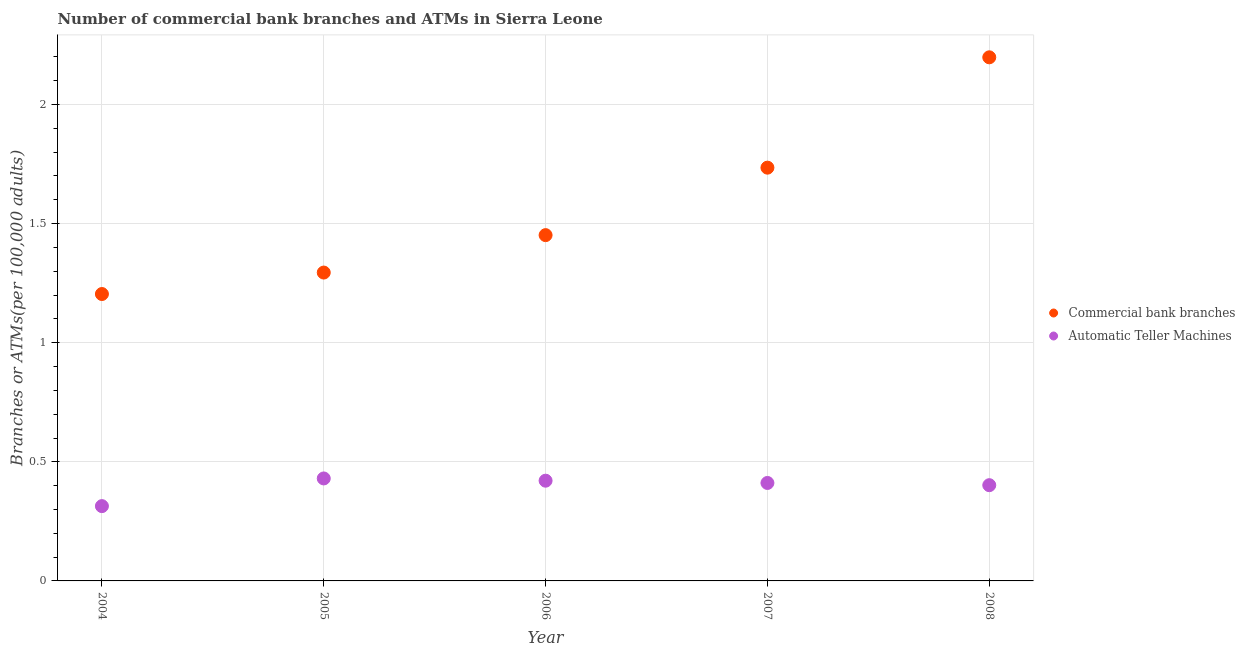How many different coloured dotlines are there?
Your response must be concise. 2. What is the number of commercal bank branches in 2005?
Offer a terse response. 1.29. Across all years, what is the maximum number of atms?
Your answer should be very brief. 0.43. Across all years, what is the minimum number of commercal bank branches?
Your response must be concise. 1.2. In which year was the number of commercal bank branches maximum?
Ensure brevity in your answer.  2008. What is the total number of atms in the graph?
Your answer should be compact. 1.98. What is the difference between the number of commercal bank branches in 2007 and that in 2008?
Your response must be concise. -0.46. What is the difference between the number of atms in 2007 and the number of commercal bank branches in 2004?
Your answer should be very brief. -0.79. What is the average number of commercal bank branches per year?
Make the answer very short. 1.58. In the year 2006, what is the difference between the number of commercal bank branches and number of atms?
Provide a short and direct response. 1.03. What is the ratio of the number of atms in 2006 to that in 2007?
Offer a very short reply. 1.02. Is the difference between the number of commercal bank branches in 2004 and 2005 greater than the difference between the number of atms in 2004 and 2005?
Offer a terse response. Yes. What is the difference between the highest and the second highest number of commercal bank branches?
Ensure brevity in your answer.  0.46. What is the difference between the highest and the lowest number of atms?
Make the answer very short. 0.12. In how many years, is the number of atms greater than the average number of atms taken over all years?
Make the answer very short. 4. Is the sum of the number of atms in 2005 and 2007 greater than the maximum number of commercal bank branches across all years?
Offer a terse response. No. Does the number of atms monotonically increase over the years?
Provide a succinct answer. No. How many dotlines are there?
Make the answer very short. 2. How many years are there in the graph?
Provide a succinct answer. 5. What is the difference between two consecutive major ticks on the Y-axis?
Keep it short and to the point. 0.5. Are the values on the major ticks of Y-axis written in scientific E-notation?
Make the answer very short. No. Does the graph contain any zero values?
Offer a very short reply. No. Does the graph contain grids?
Keep it short and to the point. Yes. How many legend labels are there?
Your answer should be compact. 2. What is the title of the graph?
Your answer should be very brief. Number of commercial bank branches and ATMs in Sierra Leone. Does "Net National savings" appear as one of the legend labels in the graph?
Make the answer very short. No. What is the label or title of the X-axis?
Your answer should be very brief. Year. What is the label or title of the Y-axis?
Provide a succinct answer. Branches or ATMs(per 100,0 adults). What is the Branches or ATMs(per 100,000 adults) of Commercial bank branches in 2004?
Provide a short and direct response. 1.2. What is the Branches or ATMs(per 100,000 adults) of Automatic Teller Machines in 2004?
Make the answer very short. 0.31. What is the Branches or ATMs(per 100,000 adults) in Commercial bank branches in 2005?
Offer a terse response. 1.29. What is the Branches or ATMs(per 100,000 adults) of Automatic Teller Machines in 2005?
Offer a terse response. 0.43. What is the Branches or ATMs(per 100,000 adults) of Commercial bank branches in 2006?
Offer a very short reply. 1.45. What is the Branches or ATMs(per 100,000 adults) of Automatic Teller Machines in 2006?
Give a very brief answer. 0.42. What is the Branches or ATMs(per 100,000 adults) of Commercial bank branches in 2007?
Provide a succinct answer. 1.73. What is the Branches or ATMs(per 100,000 adults) in Automatic Teller Machines in 2007?
Offer a very short reply. 0.41. What is the Branches or ATMs(per 100,000 adults) in Commercial bank branches in 2008?
Provide a short and direct response. 2.2. What is the Branches or ATMs(per 100,000 adults) in Automatic Teller Machines in 2008?
Your response must be concise. 0.4. Across all years, what is the maximum Branches or ATMs(per 100,000 adults) in Commercial bank branches?
Provide a succinct answer. 2.2. Across all years, what is the maximum Branches or ATMs(per 100,000 adults) in Automatic Teller Machines?
Your answer should be very brief. 0.43. Across all years, what is the minimum Branches or ATMs(per 100,000 adults) of Commercial bank branches?
Your answer should be very brief. 1.2. Across all years, what is the minimum Branches or ATMs(per 100,000 adults) of Automatic Teller Machines?
Give a very brief answer. 0.31. What is the total Branches or ATMs(per 100,000 adults) of Commercial bank branches in the graph?
Offer a very short reply. 7.88. What is the total Branches or ATMs(per 100,000 adults) in Automatic Teller Machines in the graph?
Your answer should be compact. 1.98. What is the difference between the Branches or ATMs(per 100,000 adults) of Commercial bank branches in 2004 and that in 2005?
Offer a very short reply. -0.09. What is the difference between the Branches or ATMs(per 100,000 adults) in Automatic Teller Machines in 2004 and that in 2005?
Your response must be concise. -0.12. What is the difference between the Branches or ATMs(per 100,000 adults) in Commercial bank branches in 2004 and that in 2006?
Keep it short and to the point. -0.25. What is the difference between the Branches or ATMs(per 100,000 adults) in Automatic Teller Machines in 2004 and that in 2006?
Your answer should be very brief. -0.11. What is the difference between the Branches or ATMs(per 100,000 adults) in Commercial bank branches in 2004 and that in 2007?
Provide a succinct answer. -0.53. What is the difference between the Branches or ATMs(per 100,000 adults) of Automatic Teller Machines in 2004 and that in 2007?
Offer a very short reply. -0.1. What is the difference between the Branches or ATMs(per 100,000 adults) in Commercial bank branches in 2004 and that in 2008?
Offer a very short reply. -0.99. What is the difference between the Branches or ATMs(per 100,000 adults) in Automatic Teller Machines in 2004 and that in 2008?
Keep it short and to the point. -0.09. What is the difference between the Branches or ATMs(per 100,000 adults) in Commercial bank branches in 2005 and that in 2006?
Your answer should be very brief. -0.16. What is the difference between the Branches or ATMs(per 100,000 adults) in Automatic Teller Machines in 2005 and that in 2006?
Provide a short and direct response. 0.01. What is the difference between the Branches or ATMs(per 100,000 adults) in Commercial bank branches in 2005 and that in 2007?
Offer a terse response. -0.44. What is the difference between the Branches or ATMs(per 100,000 adults) in Automatic Teller Machines in 2005 and that in 2007?
Make the answer very short. 0.02. What is the difference between the Branches or ATMs(per 100,000 adults) in Commercial bank branches in 2005 and that in 2008?
Your response must be concise. -0.9. What is the difference between the Branches or ATMs(per 100,000 adults) in Automatic Teller Machines in 2005 and that in 2008?
Your response must be concise. 0.03. What is the difference between the Branches or ATMs(per 100,000 adults) in Commercial bank branches in 2006 and that in 2007?
Offer a terse response. -0.28. What is the difference between the Branches or ATMs(per 100,000 adults) of Automatic Teller Machines in 2006 and that in 2007?
Your answer should be compact. 0.01. What is the difference between the Branches or ATMs(per 100,000 adults) of Commercial bank branches in 2006 and that in 2008?
Provide a short and direct response. -0.75. What is the difference between the Branches or ATMs(per 100,000 adults) of Automatic Teller Machines in 2006 and that in 2008?
Provide a succinct answer. 0.02. What is the difference between the Branches or ATMs(per 100,000 adults) of Commercial bank branches in 2007 and that in 2008?
Give a very brief answer. -0.46. What is the difference between the Branches or ATMs(per 100,000 adults) in Automatic Teller Machines in 2007 and that in 2008?
Give a very brief answer. 0.01. What is the difference between the Branches or ATMs(per 100,000 adults) of Commercial bank branches in 2004 and the Branches or ATMs(per 100,000 adults) of Automatic Teller Machines in 2005?
Make the answer very short. 0.77. What is the difference between the Branches or ATMs(per 100,000 adults) of Commercial bank branches in 2004 and the Branches or ATMs(per 100,000 adults) of Automatic Teller Machines in 2006?
Make the answer very short. 0.78. What is the difference between the Branches or ATMs(per 100,000 adults) in Commercial bank branches in 2004 and the Branches or ATMs(per 100,000 adults) in Automatic Teller Machines in 2007?
Provide a succinct answer. 0.79. What is the difference between the Branches or ATMs(per 100,000 adults) of Commercial bank branches in 2004 and the Branches or ATMs(per 100,000 adults) of Automatic Teller Machines in 2008?
Make the answer very short. 0.8. What is the difference between the Branches or ATMs(per 100,000 adults) in Commercial bank branches in 2005 and the Branches or ATMs(per 100,000 adults) in Automatic Teller Machines in 2006?
Provide a succinct answer. 0.87. What is the difference between the Branches or ATMs(per 100,000 adults) in Commercial bank branches in 2005 and the Branches or ATMs(per 100,000 adults) in Automatic Teller Machines in 2007?
Make the answer very short. 0.88. What is the difference between the Branches or ATMs(per 100,000 adults) of Commercial bank branches in 2005 and the Branches or ATMs(per 100,000 adults) of Automatic Teller Machines in 2008?
Ensure brevity in your answer.  0.89. What is the difference between the Branches or ATMs(per 100,000 adults) of Commercial bank branches in 2006 and the Branches or ATMs(per 100,000 adults) of Automatic Teller Machines in 2007?
Provide a succinct answer. 1.04. What is the difference between the Branches or ATMs(per 100,000 adults) in Commercial bank branches in 2006 and the Branches or ATMs(per 100,000 adults) in Automatic Teller Machines in 2008?
Provide a short and direct response. 1.05. What is the difference between the Branches or ATMs(per 100,000 adults) in Commercial bank branches in 2007 and the Branches or ATMs(per 100,000 adults) in Automatic Teller Machines in 2008?
Give a very brief answer. 1.33. What is the average Branches or ATMs(per 100,000 adults) in Commercial bank branches per year?
Offer a very short reply. 1.58. What is the average Branches or ATMs(per 100,000 adults) in Automatic Teller Machines per year?
Provide a short and direct response. 0.4. In the year 2004, what is the difference between the Branches or ATMs(per 100,000 adults) of Commercial bank branches and Branches or ATMs(per 100,000 adults) of Automatic Teller Machines?
Offer a terse response. 0.89. In the year 2005, what is the difference between the Branches or ATMs(per 100,000 adults) of Commercial bank branches and Branches or ATMs(per 100,000 adults) of Automatic Teller Machines?
Offer a terse response. 0.86. In the year 2006, what is the difference between the Branches or ATMs(per 100,000 adults) of Commercial bank branches and Branches or ATMs(per 100,000 adults) of Automatic Teller Machines?
Give a very brief answer. 1.03. In the year 2007, what is the difference between the Branches or ATMs(per 100,000 adults) in Commercial bank branches and Branches or ATMs(per 100,000 adults) in Automatic Teller Machines?
Provide a succinct answer. 1.32. In the year 2008, what is the difference between the Branches or ATMs(per 100,000 adults) of Commercial bank branches and Branches or ATMs(per 100,000 adults) of Automatic Teller Machines?
Offer a terse response. 1.8. What is the ratio of the Branches or ATMs(per 100,000 adults) in Commercial bank branches in 2004 to that in 2005?
Your answer should be compact. 0.93. What is the ratio of the Branches or ATMs(per 100,000 adults) in Automatic Teller Machines in 2004 to that in 2005?
Make the answer very short. 0.73. What is the ratio of the Branches or ATMs(per 100,000 adults) in Commercial bank branches in 2004 to that in 2006?
Provide a succinct answer. 0.83. What is the ratio of the Branches or ATMs(per 100,000 adults) in Automatic Teller Machines in 2004 to that in 2006?
Make the answer very short. 0.75. What is the ratio of the Branches or ATMs(per 100,000 adults) of Commercial bank branches in 2004 to that in 2007?
Provide a succinct answer. 0.69. What is the ratio of the Branches or ATMs(per 100,000 adults) of Automatic Teller Machines in 2004 to that in 2007?
Your response must be concise. 0.76. What is the ratio of the Branches or ATMs(per 100,000 adults) in Commercial bank branches in 2004 to that in 2008?
Your answer should be compact. 0.55. What is the ratio of the Branches or ATMs(per 100,000 adults) in Automatic Teller Machines in 2004 to that in 2008?
Ensure brevity in your answer.  0.78. What is the ratio of the Branches or ATMs(per 100,000 adults) of Commercial bank branches in 2005 to that in 2006?
Make the answer very short. 0.89. What is the ratio of the Branches or ATMs(per 100,000 adults) of Automatic Teller Machines in 2005 to that in 2006?
Your response must be concise. 1.02. What is the ratio of the Branches or ATMs(per 100,000 adults) of Commercial bank branches in 2005 to that in 2007?
Offer a very short reply. 0.75. What is the ratio of the Branches or ATMs(per 100,000 adults) of Automatic Teller Machines in 2005 to that in 2007?
Ensure brevity in your answer.  1.05. What is the ratio of the Branches or ATMs(per 100,000 adults) in Commercial bank branches in 2005 to that in 2008?
Offer a very short reply. 0.59. What is the ratio of the Branches or ATMs(per 100,000 adults) of Automatic Teller Machines in 2005 to that in 2008?
Offer a very short reply. 1.07. What is the ratio of the Branches or ATMs(per 100,000 adults) of Commercial bank branches in 2006 to that in 2007?
Provide a succinct answer. 0.84. What is the ratio of the Branches or ATMs(per 100,000 adults) of Automatic Teller Machines in 2006 to that in 2007?
Make the answer very short. 1.02. What is the ratio of the Branches or ATMs(per 100,000 adults) of Commercial bank branches in 2006 to that in 2008?
Ensure brevity in your answer.  0.66. What is the ratio of the Branches or ATMs(per 100,000 adults) of Automatic Teller Machines in 2006 to that in 2008?
Your answer should be compact. 1.05. What is the ratio of the Branches or ATMs(per 100,000 adults) of Commercial bank branches in 2007 to that in 2008?
Offer a terse response. 0.79. What is the ratio of the Branches or ATMs(per 100,000 adults) in Automatic Teller Machines in 2007 to that in 2008?
Offer a terse response. 1.02. What is the difference between the highest and the second highest Branches or ATMs(per 100,000 adults) of Commercial bank branches?
Offer a very short reply. 0.46. What is the difference between the highest and the second highest Branches or ATMs(per 100,000 adults) of Automatic Teller Machines?
Give a very brief answer. 0.01. What is the difference between the highest and the lowest Branches or ATMs(per 100,000 adults) of Commercial bank branches?
Provide a short and direct response. 0.99. What is the difference between the highest and the lowest Branches or ATMs(per 100,000 adults) of Automatic Teller Machines?
Provide a short and direct response. 0.12. 